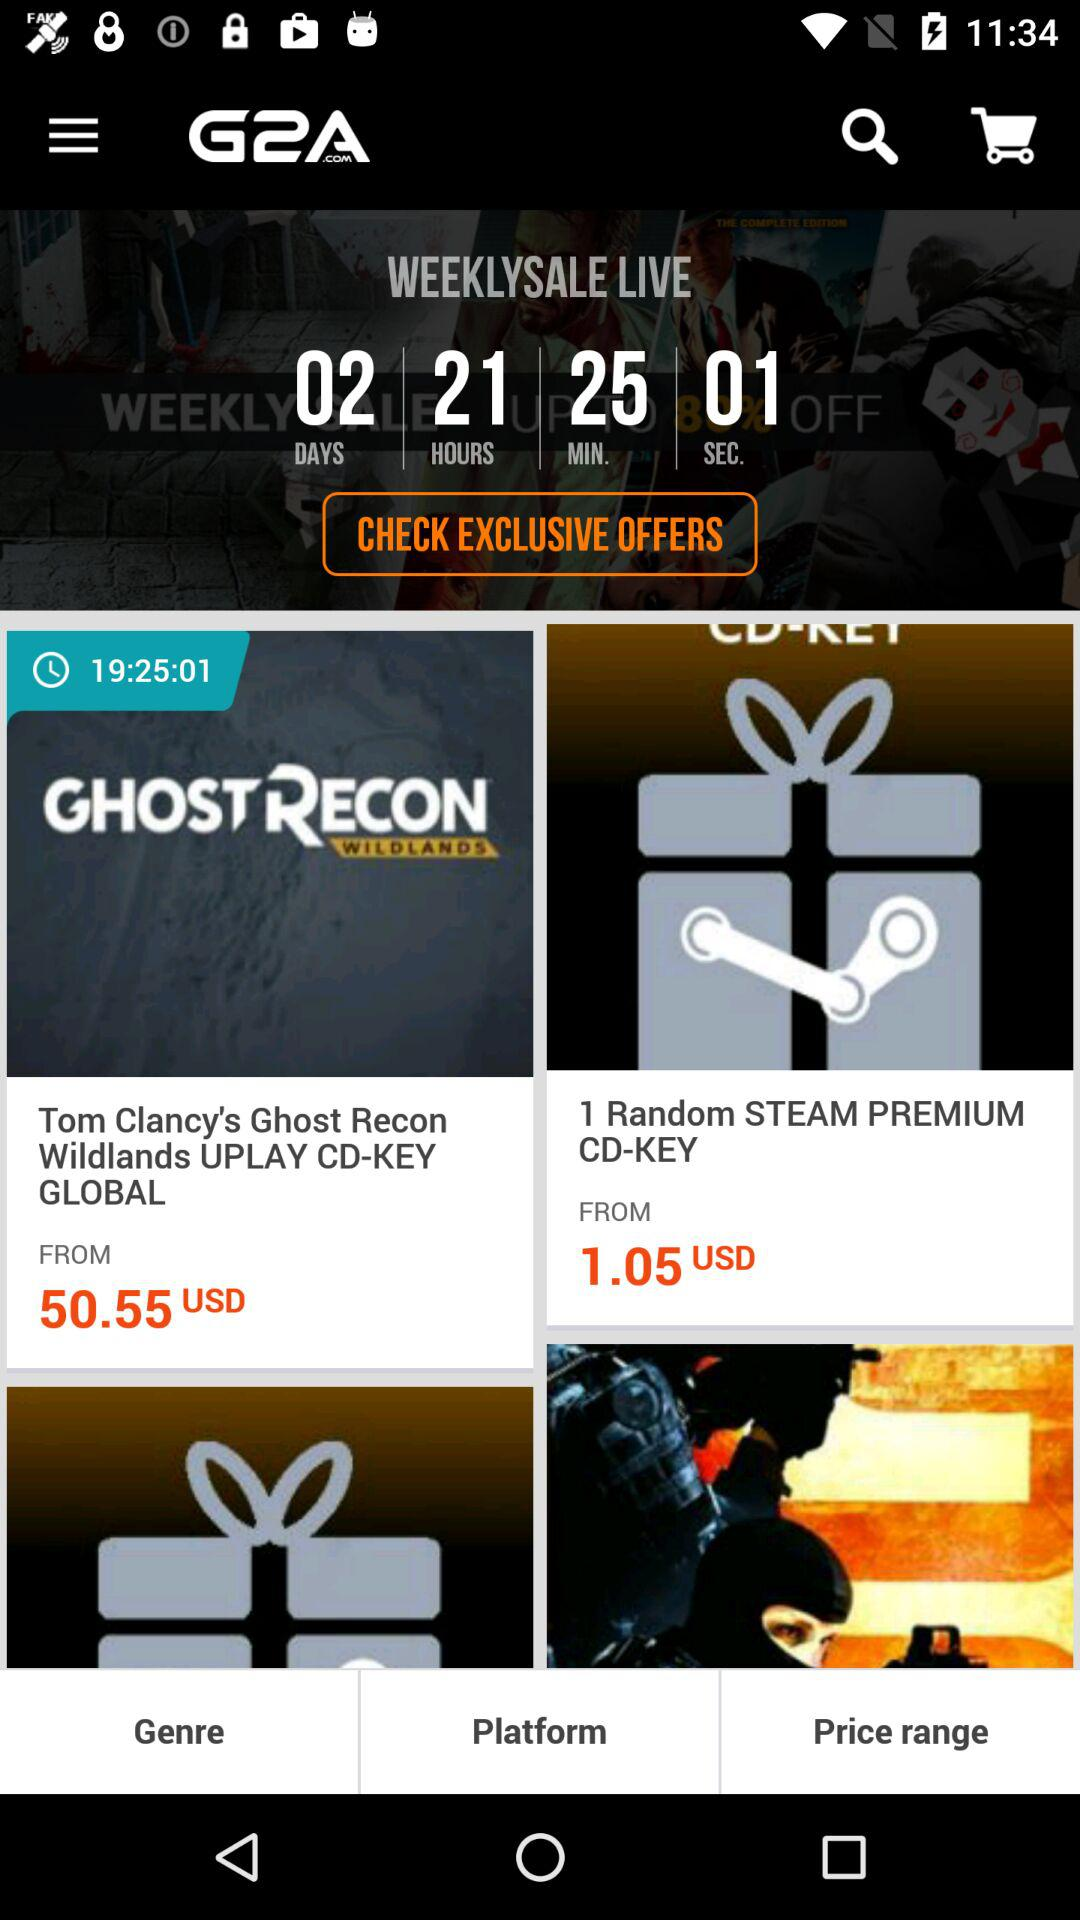What is the application name? The application name is "G2A.COM". 